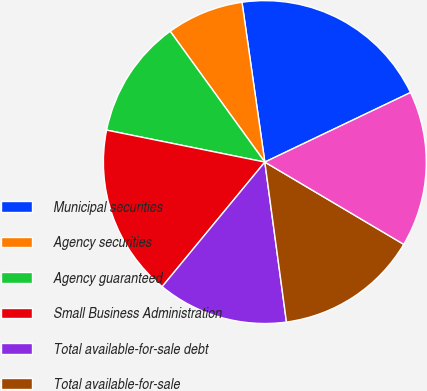Convert chart. <chart><loc_0><loc_0><loc_500><loc_500><pie_chart><fcel>Municipal securities<fcel>Agency securities<fcel>Agency guaranteed<fcel>Small Business Administration<fcel>Total available-for-sale debt<fcel>Total available-for-sale<fcel>Total investment securities<nl><fcel>20.17%<fcel>7.71%<fcel>11.86%<fcel>17.2%<fcel>13.11%<fcel>14.35%<fcel>15.6%<nl></chart> 